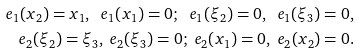<formula> <loc_0><loc_0><loc_500><loc_500>e _ { 1 } ( x _ { 2 } ) = x _ { 1 } , \ e _ { 1 } ( x _ { 1 } ) = 0 ; \ e _ { 1 } ( \xi _ { 2 } ) = 0 , \ e _ { 1 } ( \xi _ { 3 } ) = 0 , \\ e _ { 2 } ( \xi _ { 2 } ) = \xi _ { 3 } , \ e _ { 2 } ( \xi _ { 3 } ) = 0 ; \ e _ { 2 } ( x _ { 1 } ) = 0 , \ e _ { 2 } ( x _ { 2 } ) = 0 .</formula> 